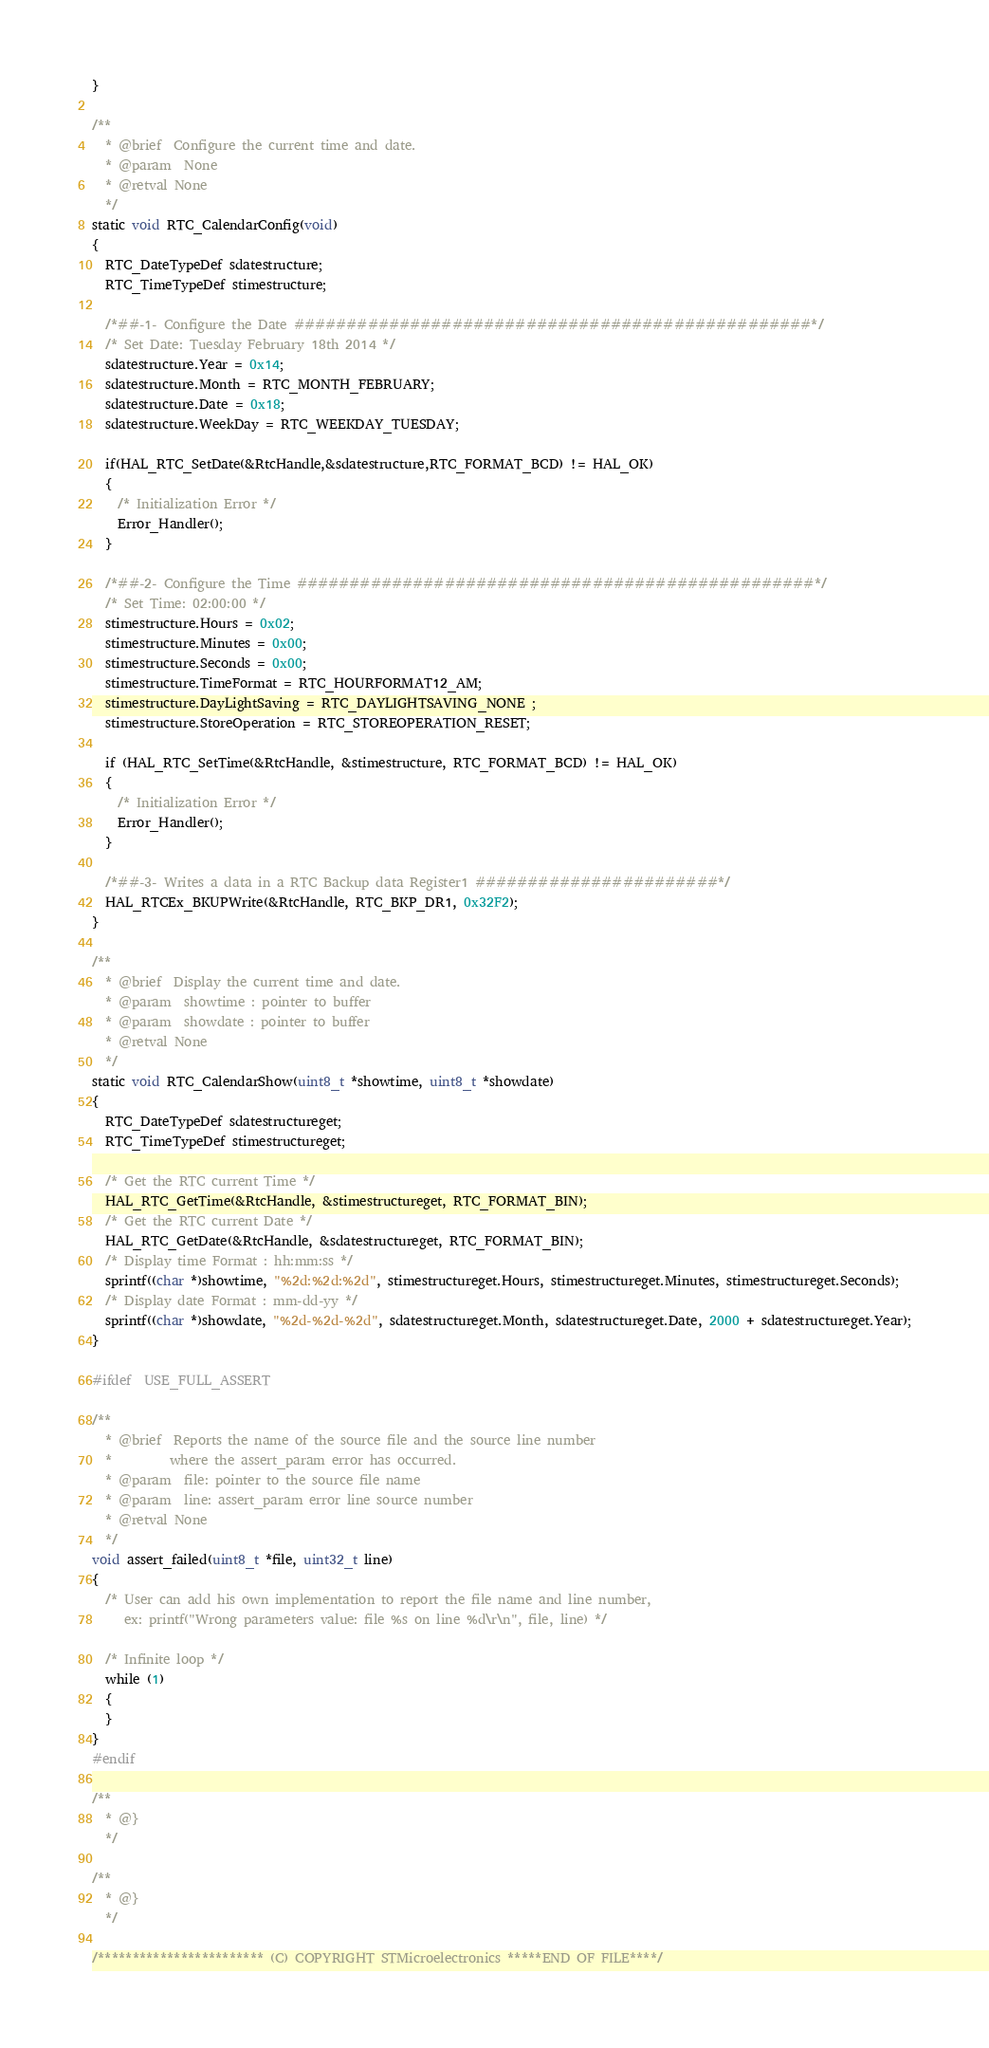<code> <loc_0><loc_0><loc_500><loc_500><_C_>}

/**
  * @brief  Configure the current time and date.
  * @param  None
  * @retval None
  */
static void RTC_CalendarConfig(void)
{
  RTC_DateTypeDef sdatestructure;
  RTC_TimeTypeDef stimestructure;

  /*##-1- Configure the Date #################################################*/
  /* Set Date: Tuesday February 18th 2014 */
  sdatestructure.Year = 0x14;
  sdatestructure.Month = RTC_MONTH_FEBRUARY;
  sdatestructure.Date = 0x18;
  sdatestructure.WeekDay = RTC_WEEKDAY_TUESDAY;
  
  if(HAL_RTC_SetDate(&RtcHandle,&sdatestructure,RTC_FORMAT_BCD) != HAL_OK)
  {
    /* Initialization Error */
    Error_Handler();
  }

  /*##-2- Configure the Time #################################################*/
  /* Set Time: 02:00:00 */
  stimestructure.Hours = 0x02;
  stimestructure.Minutes = 0x00;
  stimestructure.Seconds = 0x00;
  stimestructure.TimeFormat = RTC_HOURFORMAT12_AM;
  stimestructure.DayLightSaving = RTC_DAYLIGHTSAVING_NONE ;
  stimestructure.StoreOperation = RTC_STOREOPERATION_RESET;

  if (HAL_RTC_SetTime(&RtcHandle, &stimestructure, RTC_FORMAT_BCD) != HAL_OK)
  {
    /* Initialization Error */
    Error_Handler();
  }

  /*##-3- Writes a data in a RTC Backup data Register1 #######################*/
  HAL_RTCEx_BKUPWrite(&RtcHandle, RTC_BKP_DR1, 0x32F2);
}

/**
  * @brief  Display the current time and date.
  * @param  showtime : pointer to buffer
  * @param  showdate : pointer to buffer
  * @retval None
  */
static void RTC_CalendarShow(uint8_t *showtime, uint8_t *showdate)
{
  RTC_DateTypeDef sdatestructureget;
  RTC_TimeTypeDef stimestructureget;

  /* Get the RTC current Time */
  HAL_RTC_GetTime(&RtcHandle, &stimestructureget, RTC_FORMAT_BIN);
  /* Get the RTC current Date */
  HAL_RTC_GetDate(&RtcHandle, &sdatestructureget, RTC_FORMAT_BIN);
  /* Display time Format : hh:mm:ss */
  sprintf((char *)showtime, "%2d:%2d:%2d", stimestructureget.Hours, stimestructureget.Minutes, stimestructureget.Seconds);
  /* Display date Format : mm-dd-yy */
  sprintf((char *)showdate, "%2d-%2d-%2d", sdatestructureget.Month, sdatestructureget.Date, 2000 + sdatestructureget.Year);
}

#ifdef  USE_FULL_ASSERT

/**
  * @brief  Reports the name of the source file and the source line number
  *         where the assert_param error has occurred.
  * @param  file: pointer to the source file name
  * @param  line: assert_param error line source number
  * @retval None
  */
void assert_failed(uint8_t *file, uint32_t line)
{
  /* User can add his own implementation to report the file name and line number,
     ex: printf("Wrong parameters value: file %s on line %d\r\n", file, line) */

  /* Infinite loop */
  while (1)
  {
  }
}
#endif

/**
  * @}
  */

/**
  * @}
  */

/************************ (C) COPYRIGHT STMicroelectronics *****END OF FILE****/
</code> 